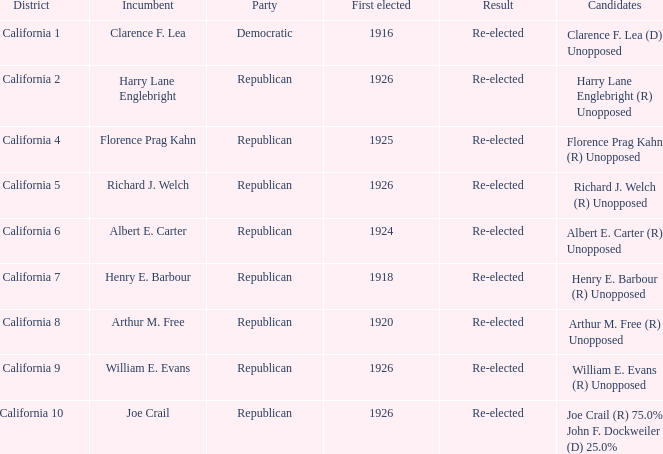What is the district where the democratic party is in power? California 1. 